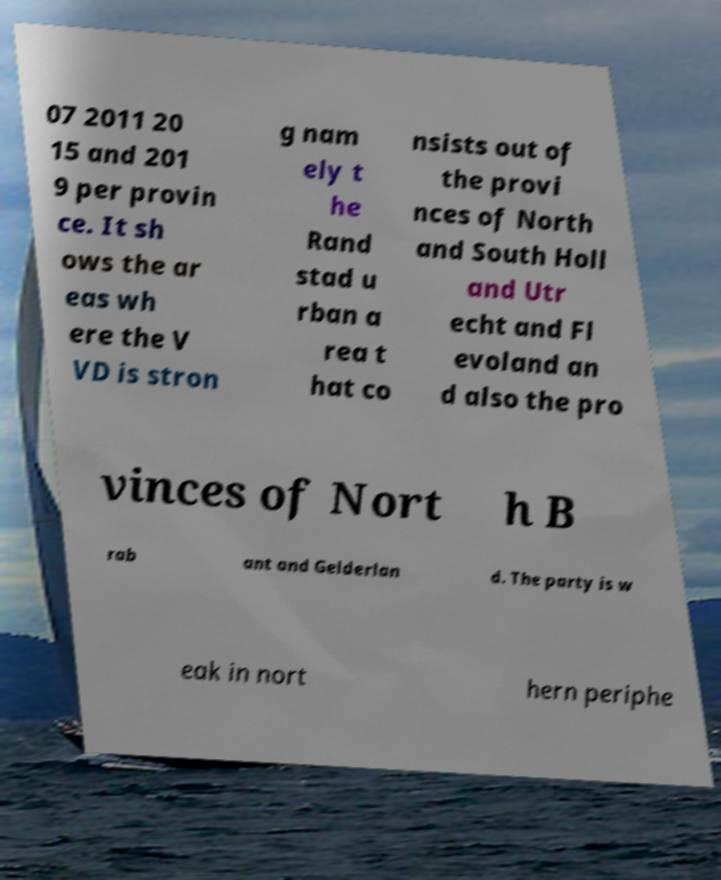There's text embedded in this image that I need extracted. Can you transcribe it verbatim? 07 2011 20 15 and 201 9 per provin ce. It sh ows the ar eas wh ere the V VD is stron g nam ely t he Rand stad u rban a rea t hat co nsists out of the provi nces of North and South Holl and Utr echt and Fl evoland an d also the pro vinces of Nort h B rab ant and Gelderlan d. The party is w eak in nort hern periphe 